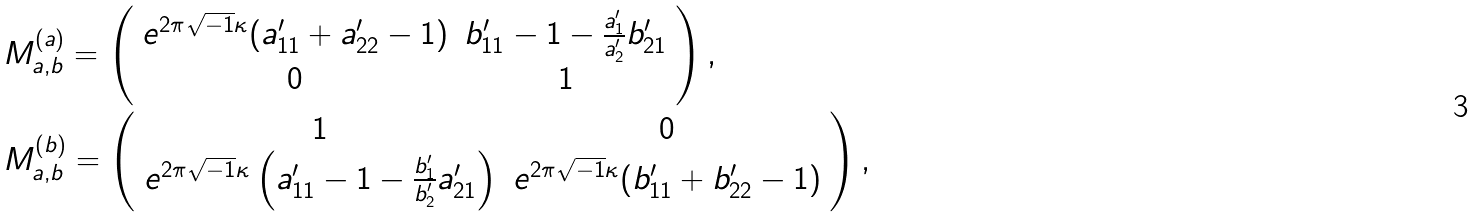Convert formula to latex. <formula><loc_0><loc_0><loc_500><loc_500>& M ^ { ( a ) } _ { a , b } = \left ( \begin{array} { c c } e ^ { 2 \pi \sqrt { - 1 } \kappa } ( a ^ { \prime } _ { 1 1 } + a ^ { \prime } _ { 2 2 } - 1 ) & b ^ { \prime } _ { 1 1 } - 1 - \frac { a ^ { \prime } _ { 1 } } { a ^ { \prime } _ { 2 } } b ^ { \prime } _ { 2 1 } \\ 0 & 1 \end{array} \right ) , \\ & M ^ { ( b ) } _ { a , b } = \left ( \begin{array} { c c } 1 & 0 \\ e ^ { 2 \pi \sqrt { - 1 } \kappa } \left ( a ^ { \prime } _ { 1 1 } - 1 - \frac { b ^ { \prime } _ { 1 } } { b ^ { \prime } _ { 2 } } a ^ { \prime } _ { 2 1 } \right ) & e ^ { 2 \pi \sqrt { - 1 } \kappa } ( b ^ { \prime } _ { 1 1 } + b ^ { \prime } _ { 2 2 } - 1 ) \end{array} \right ) ,</formula> 